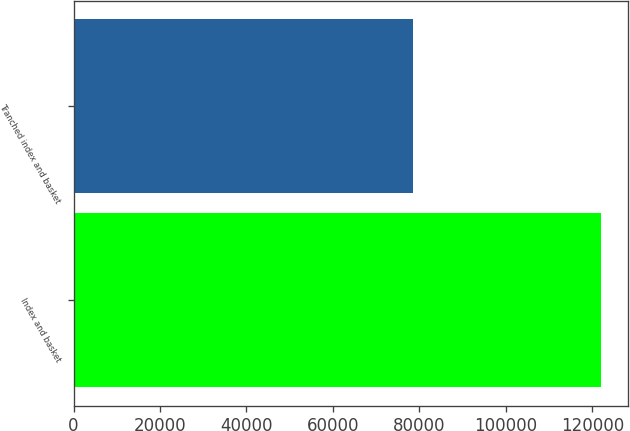Convert chart to OTSL. <chart><loc_0><loc_0><loc_500><loc_500><bar_chart><fcel>Index and basket<fcel>Tranched index and basket<nl><fcel>122061<fcel>78505<nl></chart> 